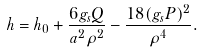Convert formula to latex. <formula><loc_0><loc_0><loc_500><loc_500>h = h _ { 0 } + \frac { 6 g _ { s } Q } { a ^ { 2 } \rho ^ { 2 } } - \frac { 1 8 ( g _ { s } P ) ^ { 2 } } { \rho ^ { 4 } } .</formula> 